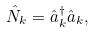<formula> <loc_0><loc_0><loc_500><loc_500>\hat { N } _ { k } = \hat { a } _ { k } ^ { \dagger } \hat { a } _ { k } ,</formula> 